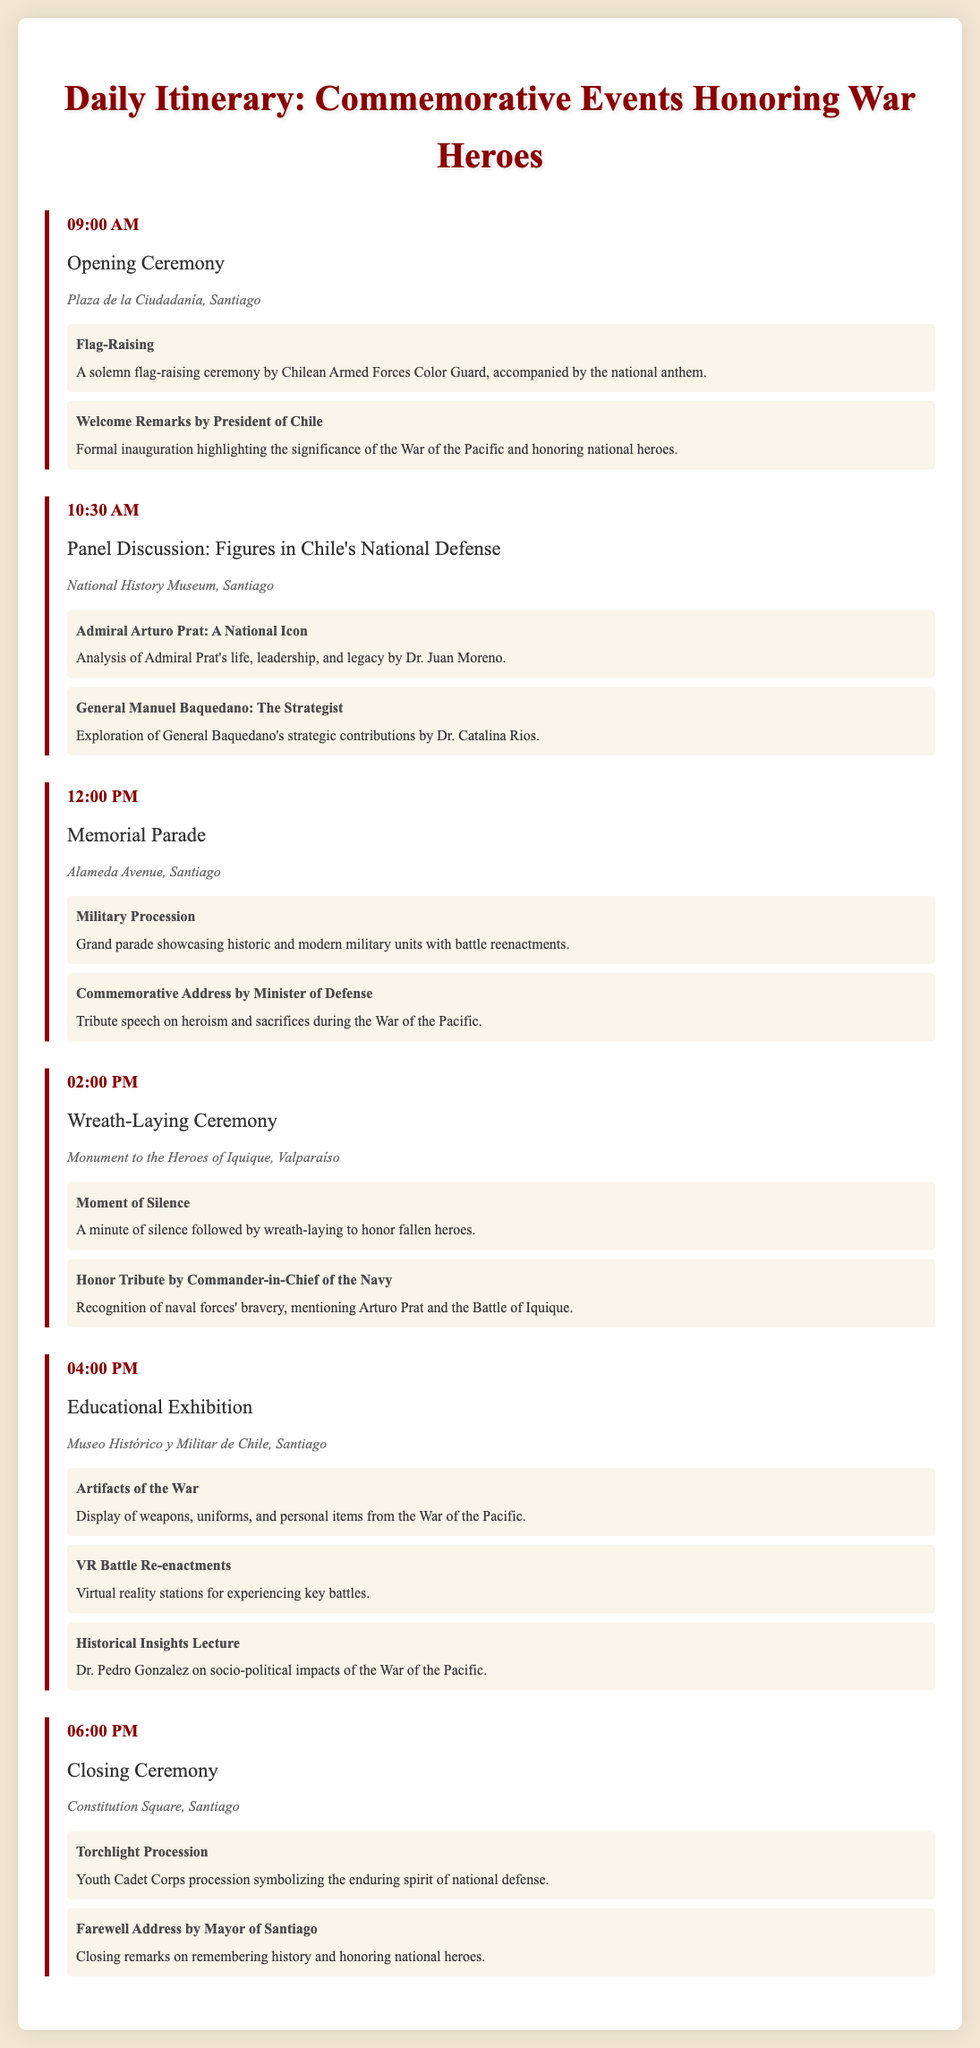What time does the Opening Ceremony start? The opening ceremony starts at 09:00 AM according to the itinerary.
Answer: 09:00 AM Where is the Memorial Parade taking place? The Memorial Parade is scheduled to take place along Alameda Avenue, Santiago, as indicated in the document.
Answer: Alameda Avenue, Santiago Who delivers the closing remarks at the Closing Ceremony? The Mayor of Santiago gives the farewell address during the Closing Ceremony, as stated in the document.
Answer: Mayor of Santiago Which event includes a wreath-laying ceremony? The Wreath-Laying Ceremony is a part of the events scheduled at 02:00 PM at the Monument to the Heroes of Iquique.
Answer: Wreath-Laying Ceremony What is the highlight of the Educational Exhibition that features virtual reality? The highlight item in the Educational Exhibition that features virtual reality is the VR Battle Re-enactments.
Answer: VR Battle Re-enactments How many discussions are there about specific figures in Chile's national defense? Two panel discussions are dedicated to specific figures in Chile's national defense.
Answer: Two What significant action occurs at 12:00 PM on Memorial Parade day? At 12:00 PM, the Grand parade showcasing historic and modern military units takes place as part of the Memorial Parade.
Answer: Grand parade What is the location of the final ceremony of the day? The final ceremony of the day, the Closing Ceremony, is located at Constitution Square, Santiago.
Answer: Constitution Square, Santiago 